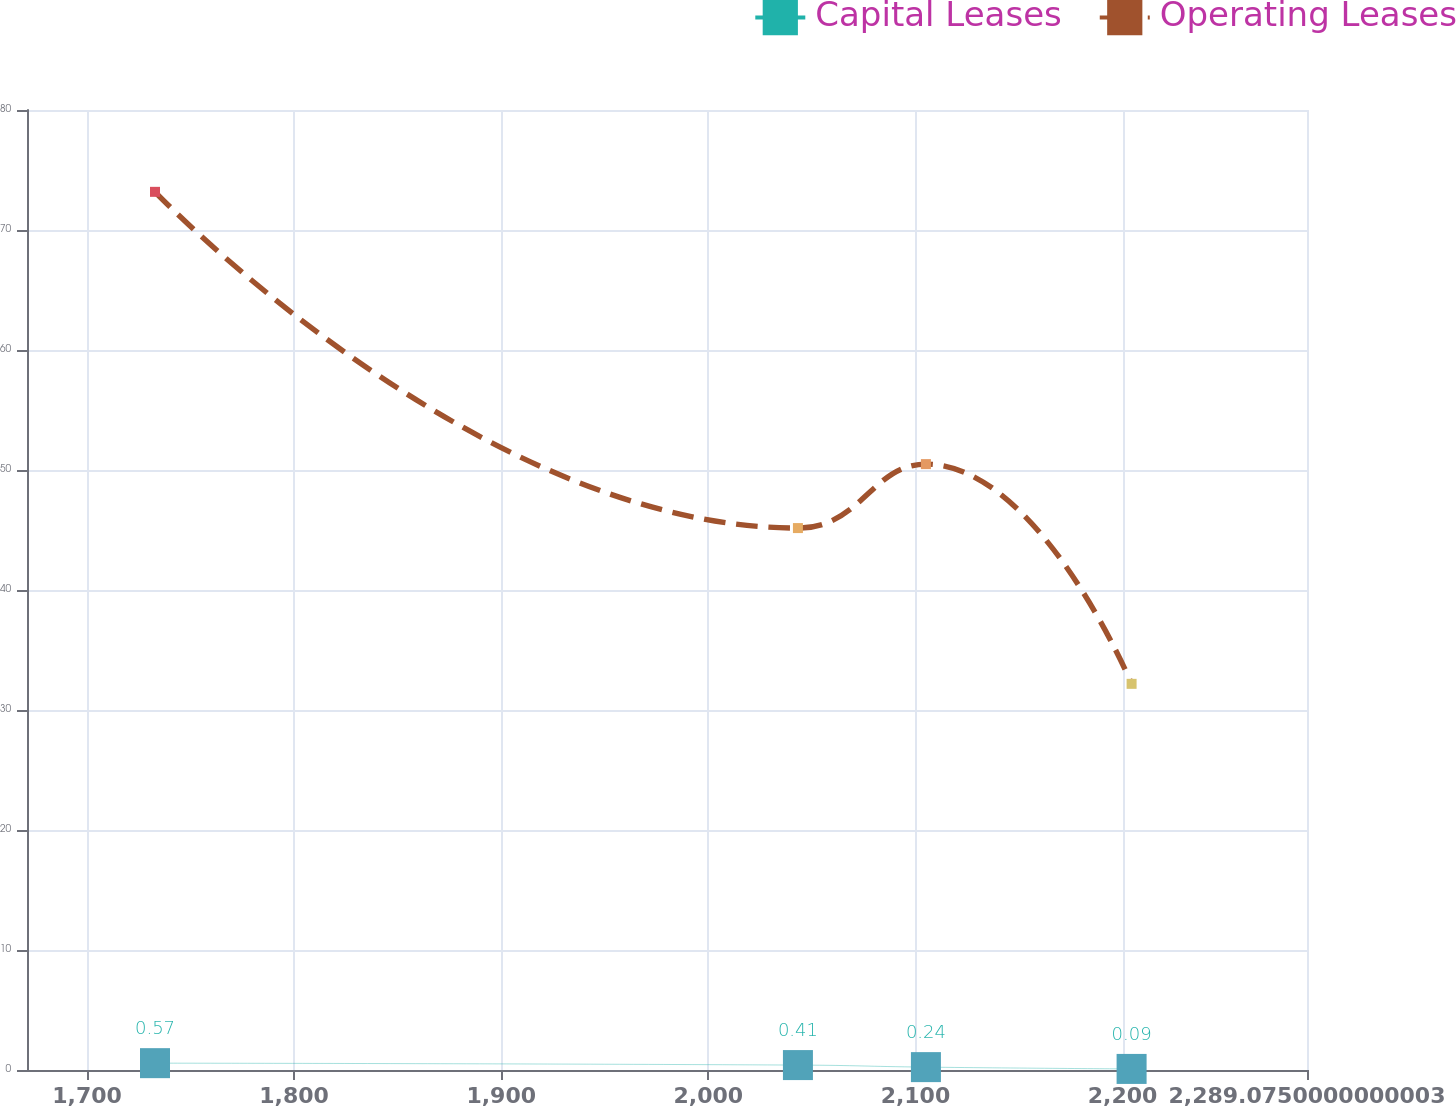Convert chart to OTSL. <chart><loc_0><loc_0><loc_500><loc_500><line_chart><ecel><fcel>Capital Leases<fcel>Operating Leases<nl><fcel>1732.83<fcel>0.57<fcel>73.18<nl><fcel>2043.27<fcel>0.41<fcel>45.16<nl><fcel>2105.07<fcel>0.24<fcel>50.49<nl><fcel>2204.38<fcel>0.09<fcel>32.18<nl><fcel>2350.88<fcel>0.14<fcel>24.32<nl></chart> 